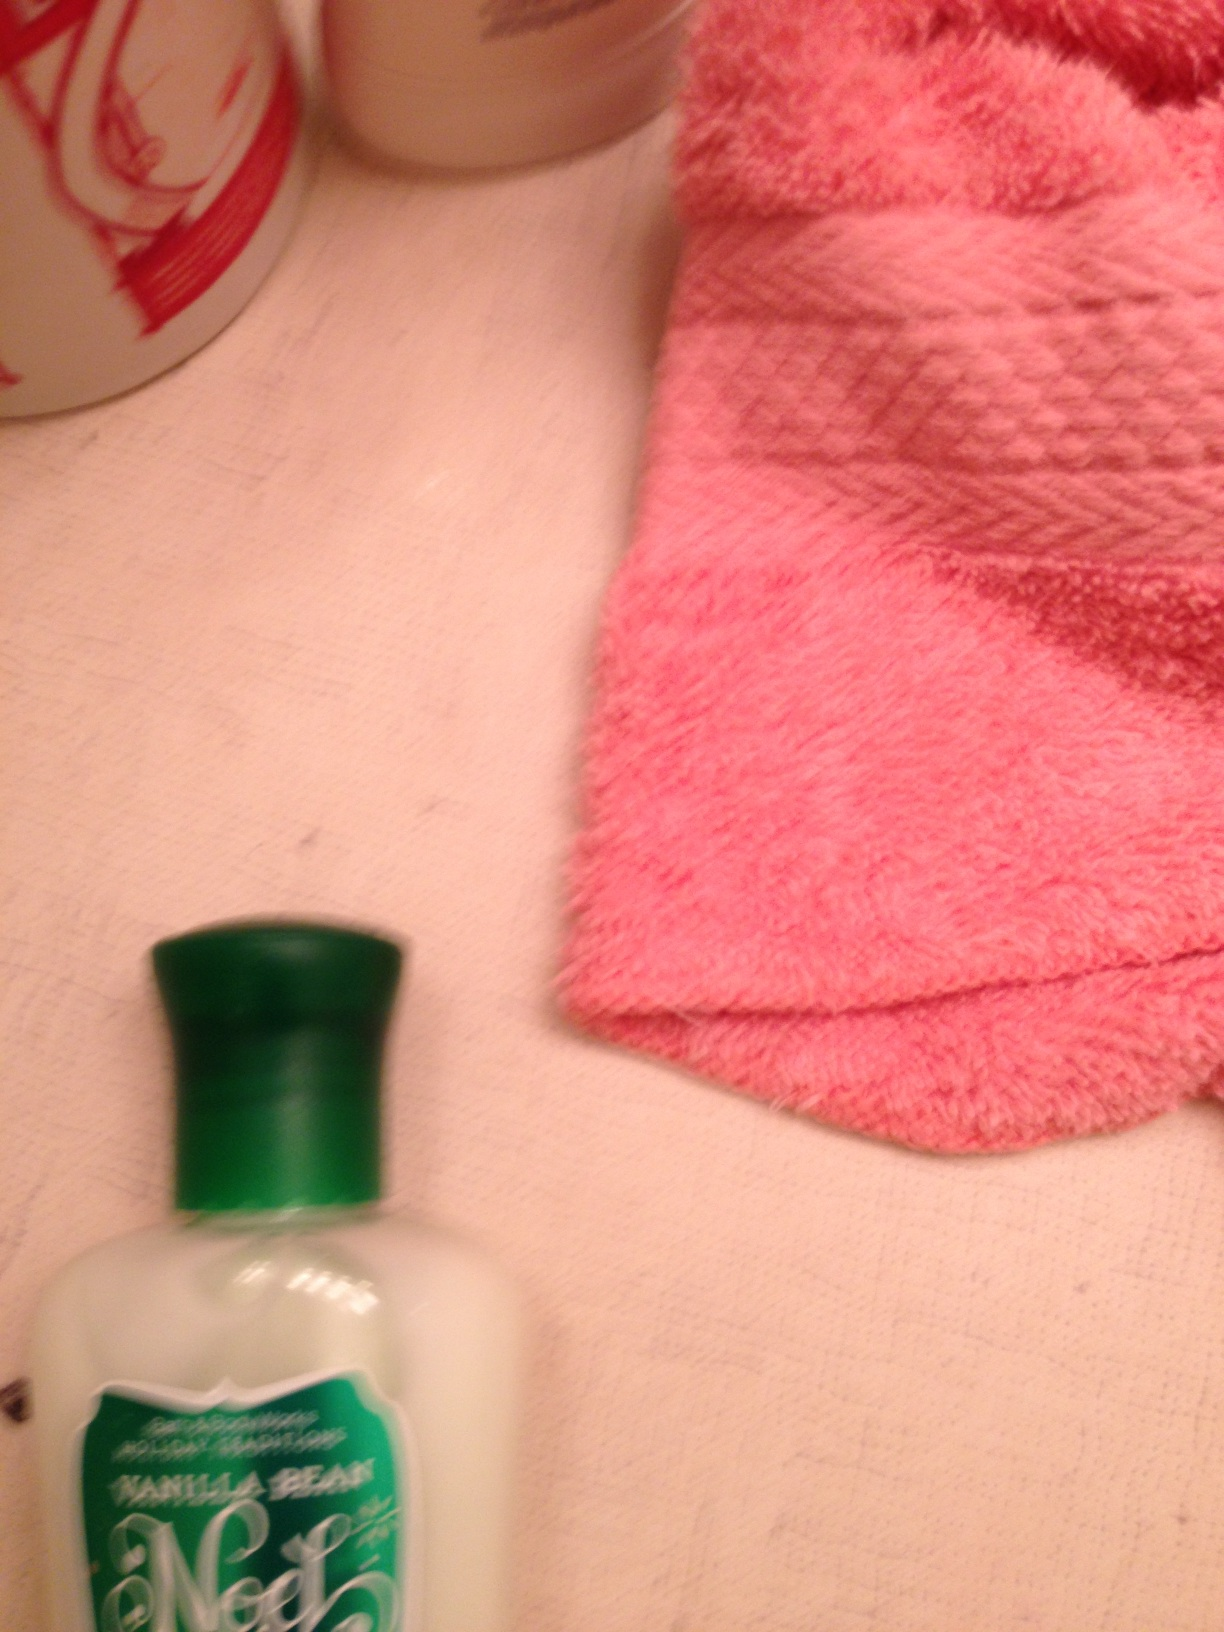Imagine an imaginative scenario involving these items. Imagine that the bottle of lotion is a magic potion that grants whoever applies it the power to teleport. The pink towel is enchanted, and when one dries their hands with it, they gain the ability to speak and understand any language. The bathroom, then, becomes a hidden portal to different dimensions where various adventures await! What could be a realistic use scenario for these items? In a realistic scenario, the lotion could be used as part of a daily skincare routine. The pink towel might be used to dry hands after washing them, and the other bottles in the background are likely personal care products such as shampoo, conditioner, or body wash, used during bathing or showering. Can you provide a detailed explanation of how to properly use body lotion? Certainly! To properly use body lotion, start by washing and drying your skin thoroughly. Apply a moderate amount of lotion to your hand and spread it evenly over the desired area, using gentle, upward strokes. Focus on dry areas such as elbows, knees, and hands. It's best to apply lotion immediately after a shower or bath when your skin is slightly damp, as this helps to lock in moisture. For the best results, let the lotion absorb into the skin for a few minutes before getting dressed. Using lotion regularly can keep your skin hydrated, smooth, and healthy. Can you describe a very short scenario in which all these items are used? A person finishes showering, dries their hands with the pink towel, then applies the 'Vanilla Bean Noel' lotion to keep their skin soft and hydrated. 